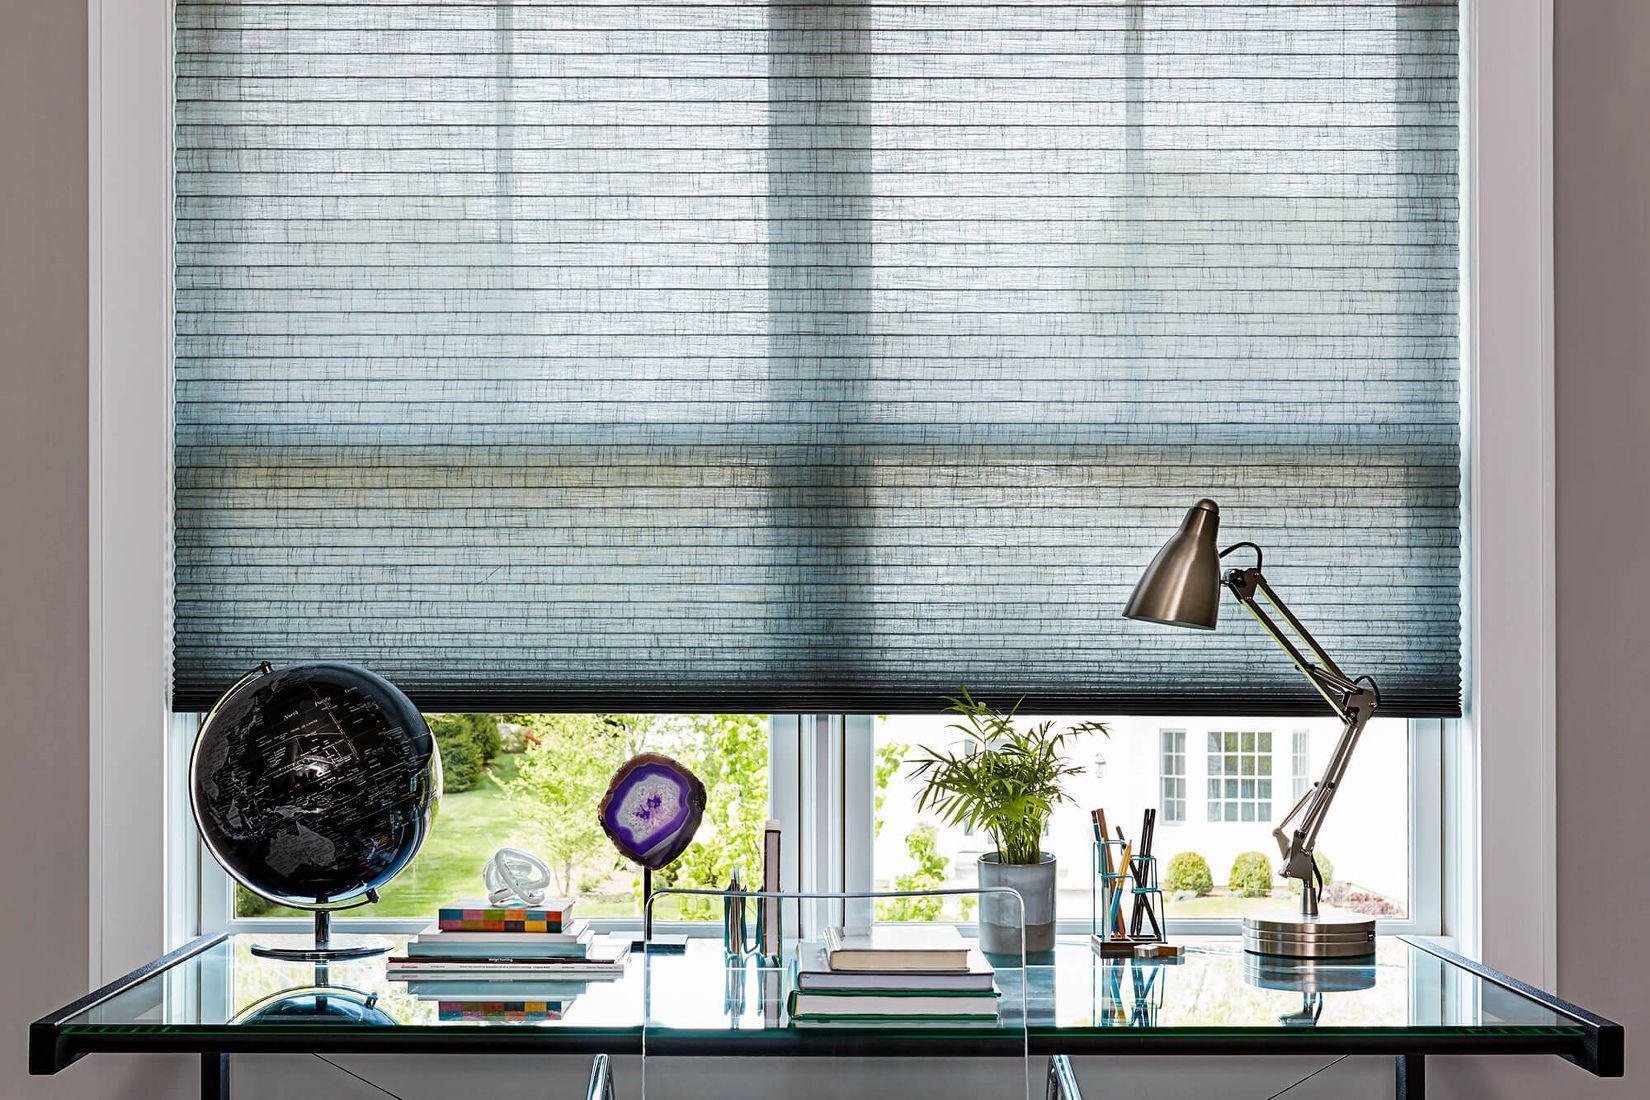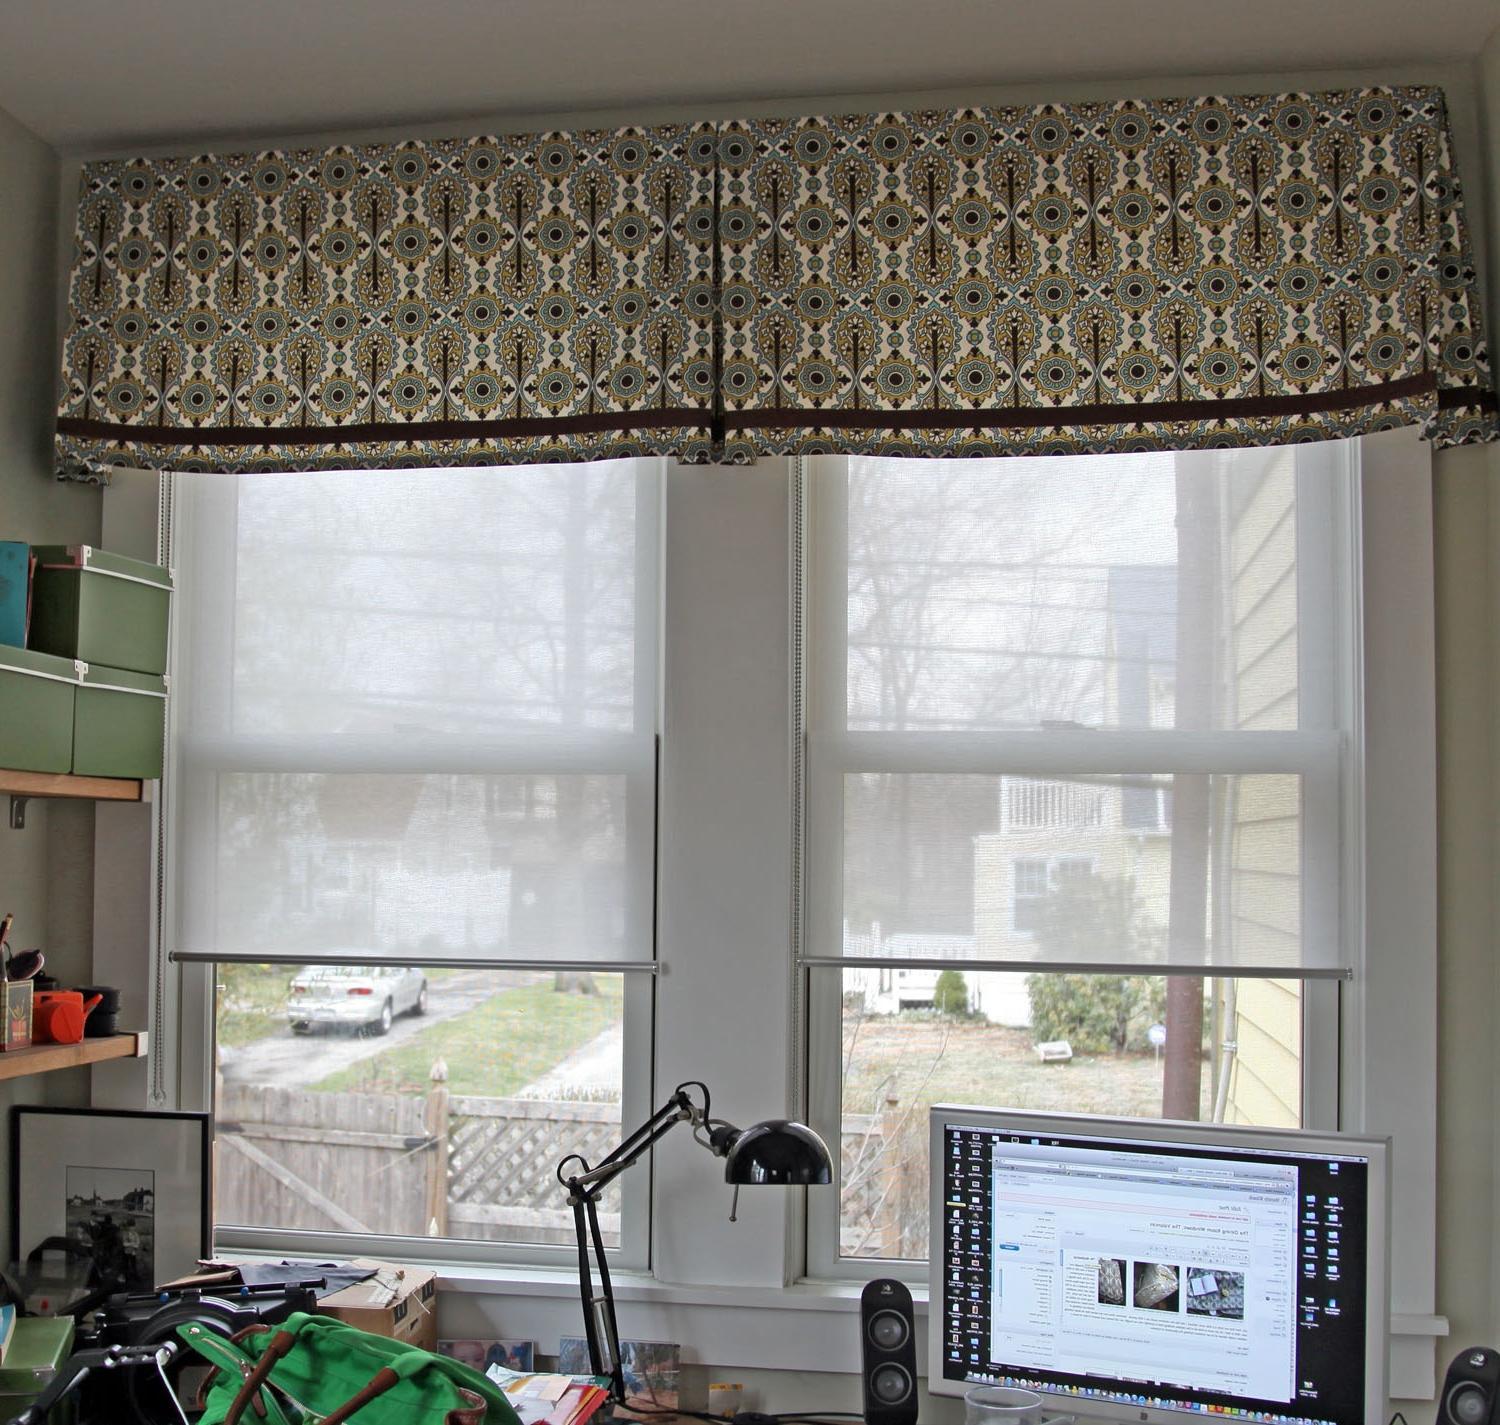The first image is the image on the left, the second image is the image on the right. For the images displayed, is the sentence "There are five to six shades." factually correct? Answer yes or no. No. The first image is the image on the left, the second image is the image on the right. Examine the images to the left and right. Is the description "There are the same number of windows in both images." accurate? Answer yes or no. Yes. 